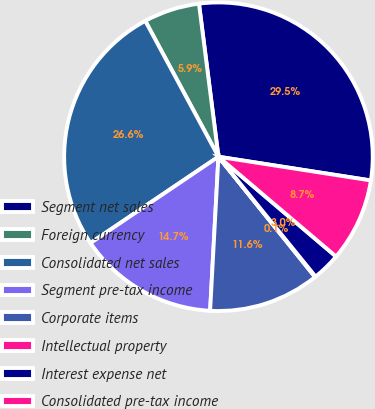Convert chart. <chart><loc_0><loc_0><loc_500><loc_500><pie_chart><fcel>Segment net sales<fcel>Foreign currency<fcel>Consolidated net sales<fcel>Segment pre-tax income<fcel>Corporate items<fcel>Intellectual property<fcel>Interest expense net<fcel>Consolidated pre-tax income<nl><fcel>29.47%<fcel>5.85%<fcel>26.58%<fcel>14.69%<fcel>11.63%<fcel>0.07%<fcel>2.96%<fcel>8.74%<nl></chart> 